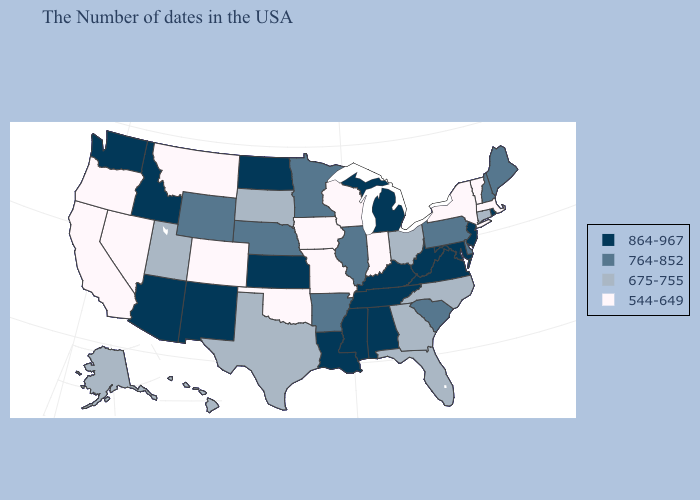What is the value of Maryland?
Concise answer only. 864-967. What is the highest value in the USA?
Answer briefly. 864-967. Does Tennessee have the highest value in the South?
Write a very short answer. Yes. Does Louisiana have a lower value than Delaware?
Write a very short answer. No. Name the states that have a value in the range 764-852?
Be succinct. Maine, New Hampshire, Delaware, Pennsylvania, South Carolina, Illinois, Arkansas, Minnesota, Nebraska, Wyoming. Does Kansas have the lowest value in the MidWest?
Quick response, please. No. Does the first symbol in the legend represent the smallest category?
Quick response, please. No. What is the value of Hawaii?
Write a very short answer. 675-755. Does Utah have the highest value in the USA?
Concise answer only. No. What is the value of West Virginia?
Short answer required. 864-967. What is the value of Virginia?
Short answer required. 864-967. How many symbols are there in the legend?
Give a very brief answer. 4. What is the value of Pennsylvania?
Write a very short answer. 764-852. What is the value of Illinois?
Concise answer only. 764-852. Which states have the lowest value in the South?
Keep it brief. Oklahoma. 